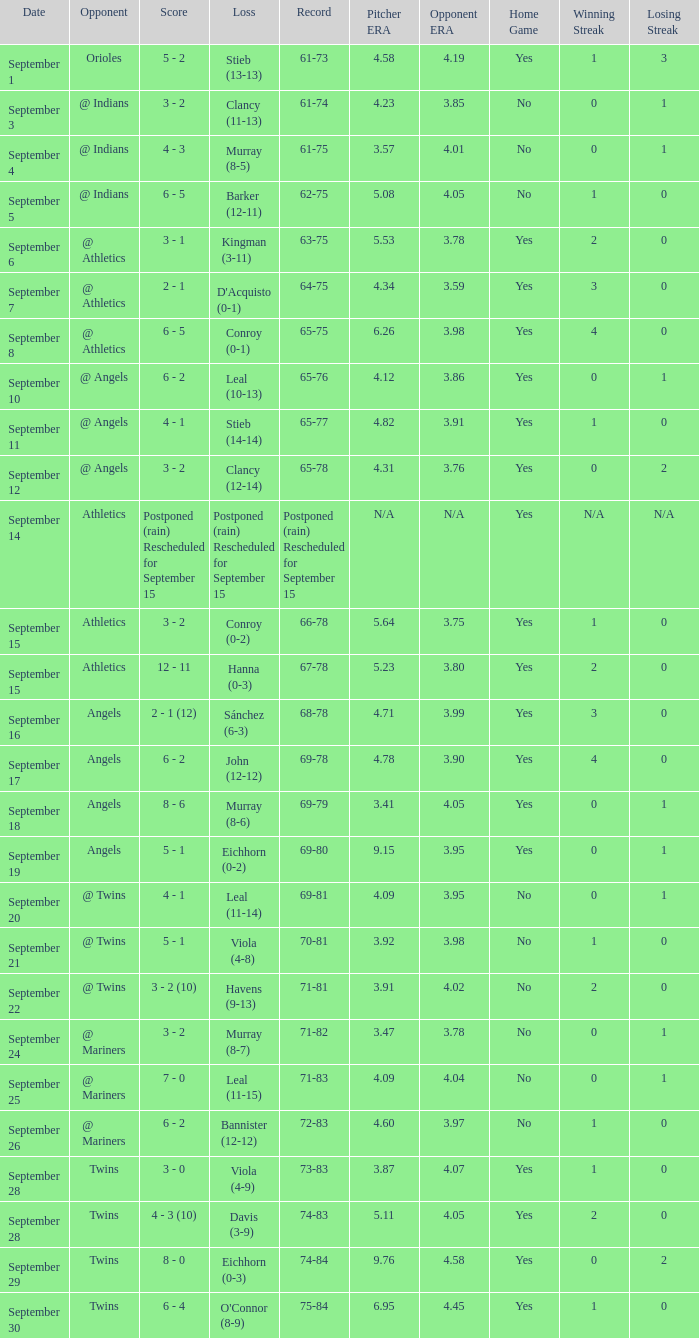Name the score which has record of 73-83 3 - 0. 